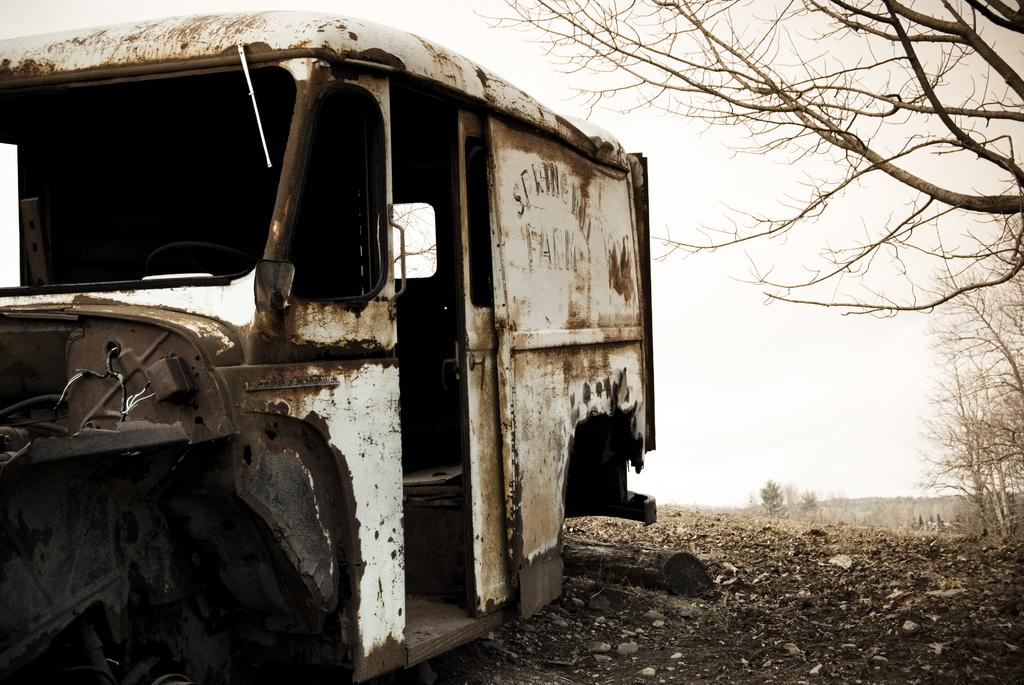What is the main object on the ground in the image? There is a vehicle on the ground in the image. What type of natural elements can be seen in the image? There are stones, leaves, and trees in the image. What is visible in the background of the image? The sky is visible in the background of the image. What type of plot is the bird flying over in the image? There is no bird present in the image, so it is not possible to determine the type of plot the bird might be flying over. Is there a camp visible in the image? There is no camp present in the image. 